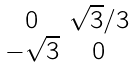<formula> <loc_0><loc_0><loc_500><loc_500>\begin{smallmatrix} 0 & \sqrt { 3 } / 3 \\ - \sqrt { 3 } & 0 \end{smallmatrix}</formula> 